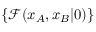Convert formula to latex. <formula><loc_0><loc_0><loc_500><loc_500>\{ \mathcal { F } ( x _ { A } , x _ { B } | 0 ) \}</formula> 